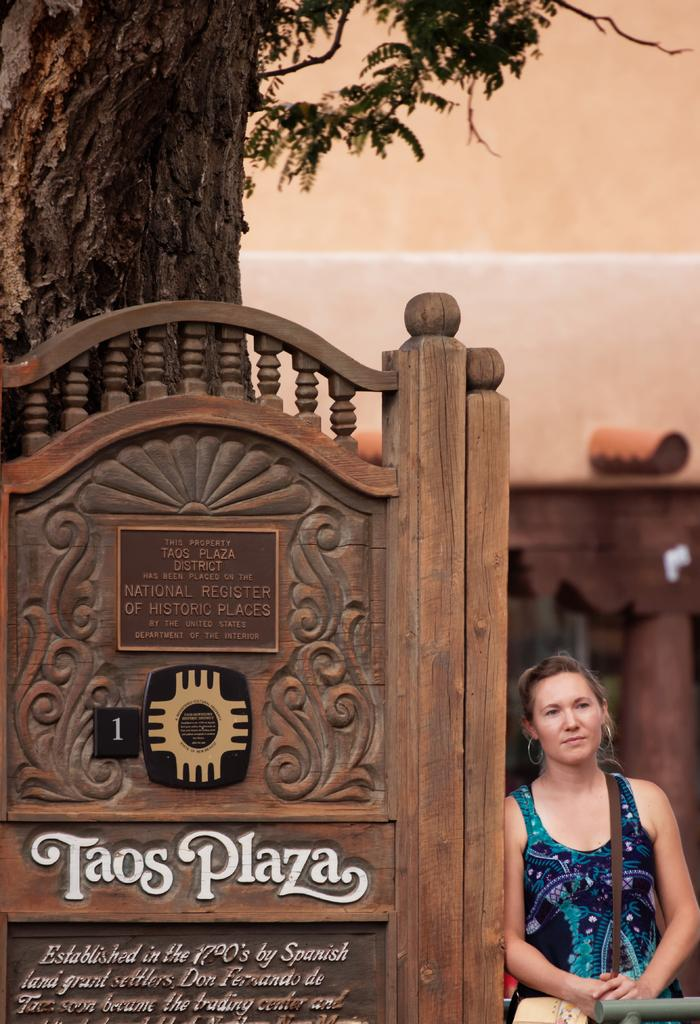What is on the wooden board in the image? There is text on the wooden board in the image. What is the woman wearing in the image? The woman is wearing a bag in the image. What type of structure can be seen in the image? There is a wall in the image. What part of a tree is visible in the image? The bark of a tree with branches is visible in the image. Can you see a hammer being used on the wooden board in the image? There is no hammer present in the image. Is the woman biting the bark of the tree in the image? There is no indication of the woman biting the bark of the tree in the image. 